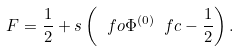<formula> <loc_0><loc_0><loc_500><loc_500>F = \frac { 1 } { 2 } + s \left ( \ f o \Phi ^ { ( 0 ) } \ f c - \frac { 1 } { 2 } \right ) .</formula> 